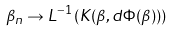Convert formula to latex. <formula><loc_0><loc_0><loc_500><loc_500>\beta _ { n } \rightarrow L ^ { - 1 } \left ( K ( \beta , d \Phi ( \beta ) ) \right )</formula> 